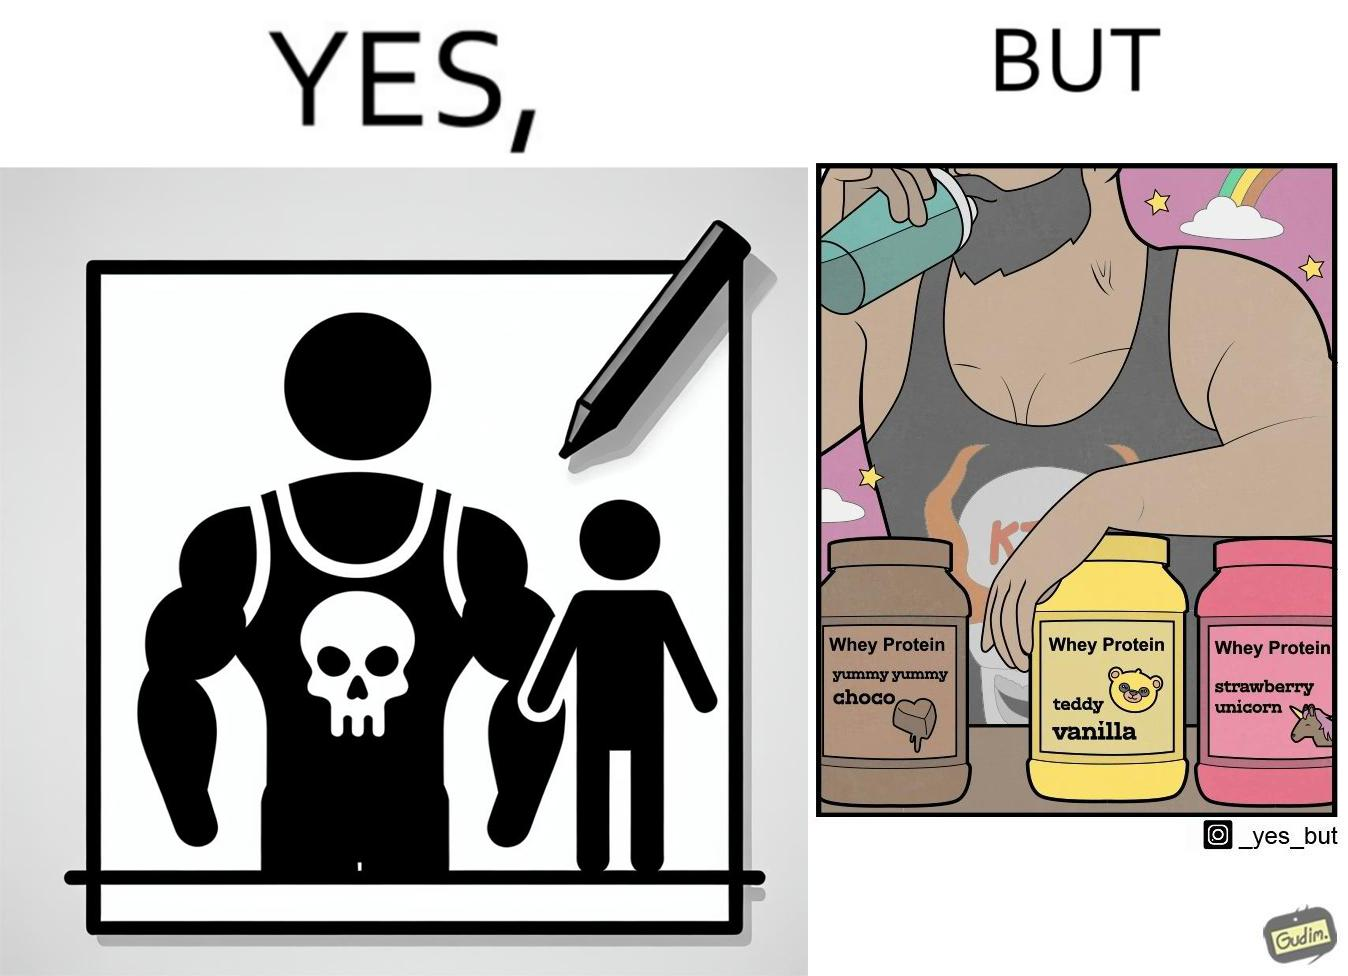What makes this image funny or satirical? The image is funny because a well-built person wearing an aggressive tank-top with the word "KILL" on an image of a skull is having very childish flavours of whey protein such as teddy vanilla, yummy yummy choco, and strawberry vanilla, contrary to the person's external persona. This depicts the metaphor 'Do not judge a book by its cover'. 